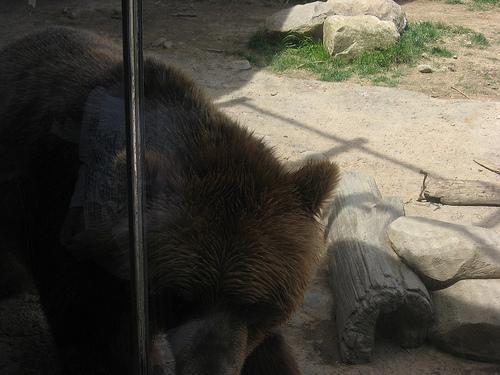How many bears are there?
Give a very brief answer. 1. How many bears are pictured?
Give a very brief answer. 1. How many animals are pictured here?
Give a very brief answer. 1. How many people appear in this photo?
Give a very brief answer. 0. 